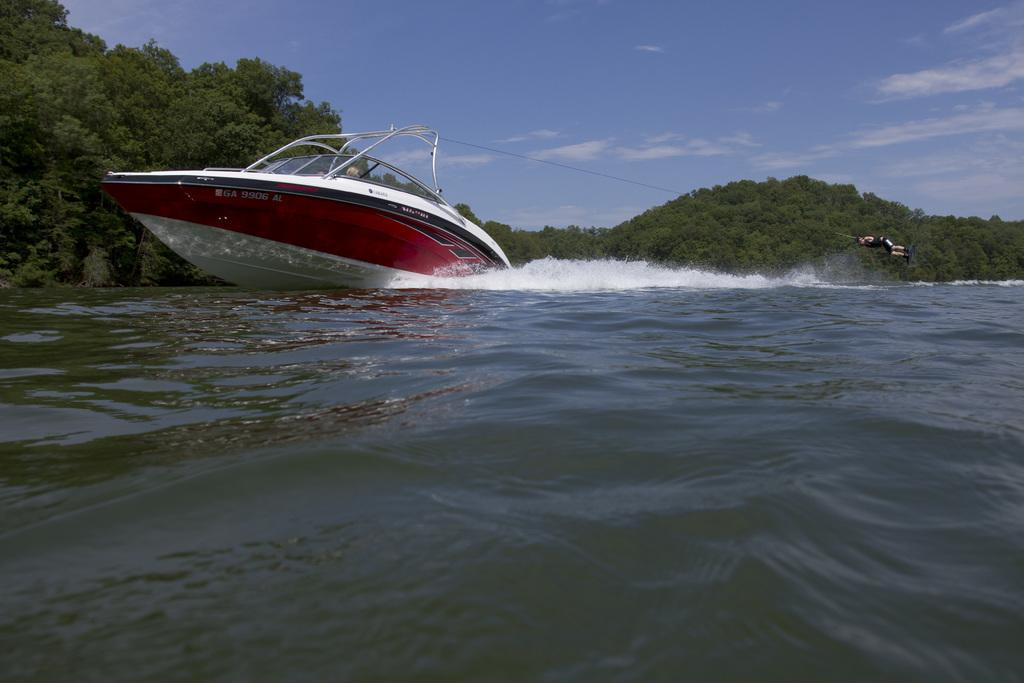Who is the person in the image? There is a man in the image. What is the man doing in the image? The man is wake surfing. What is the source of the waves for wake surfing in the image? The wake surfing is happening behind a boat in the image. Where is the wake surfing activity taking place? The activity is taking place in a river. What can be seen in the background of the image? There are mountains covered with trees in the background of the image. What is the color of the sky in the image? The sky is blue in the image. What type of sand can be seen on the stick held by the man in the image? There is no sand or stick present in the image. The man is wake surfing behind a boat in a river, and the only visible objects are the man, the boat, and the surrounding environment. 